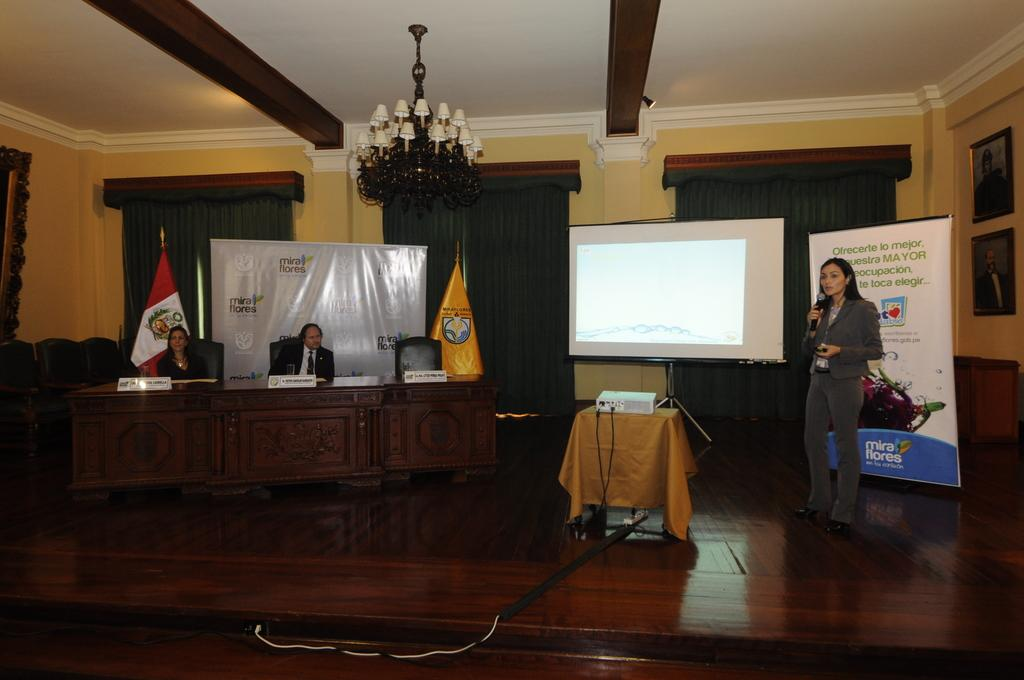What is the woman in the image holding? The woman is holding a microphone. What can be seen in the background of the image? There is a screen and a banner in the background of the image. How many other people are in the image besides the woman? There are two other persons sitting on chairs in the image. What type of fabric is present in the image? There is a curtain in the image. What type of structure is visible in the image? There is a wall in the image. What type of love can be seen on the banner in the image? There is no mention of love on the banner in the image; it only contains text or a design. 